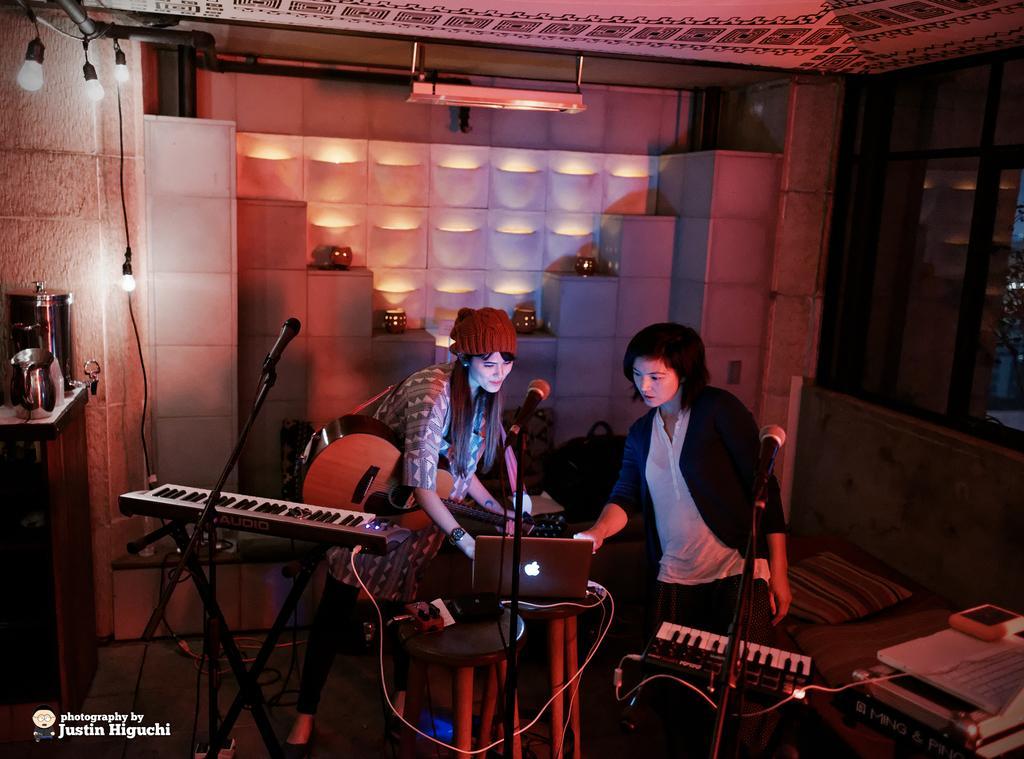How would you summarize this image in a sentence or two? In this picture there are two girl working on the laptop. In the front there is a piano and some musical instruments with microphone. In the background there is a white wall and some lights. 